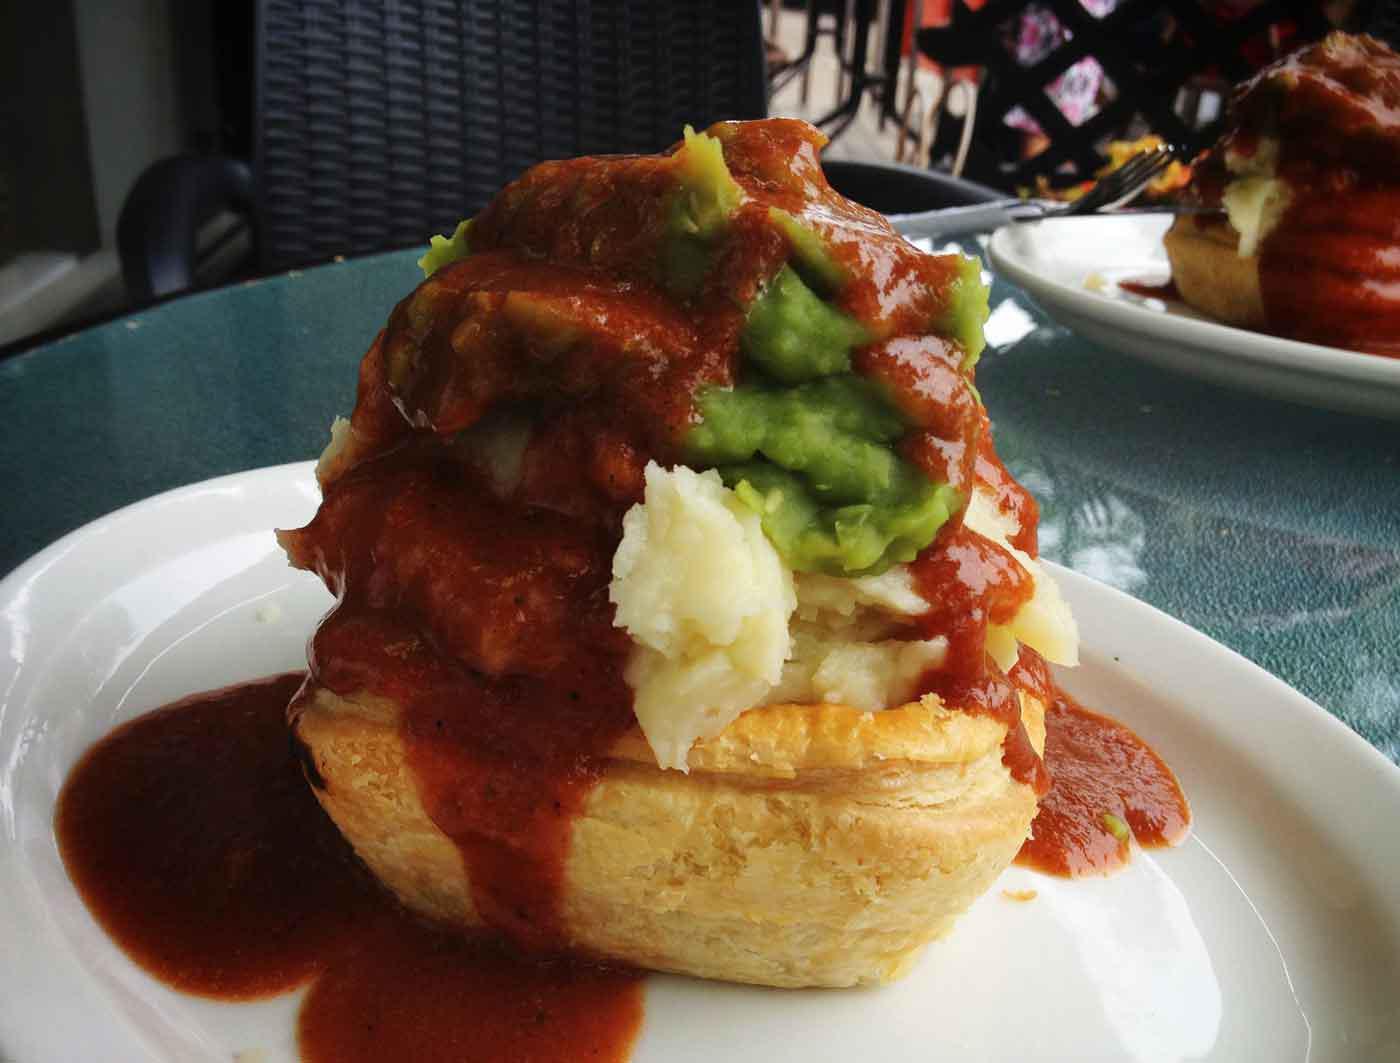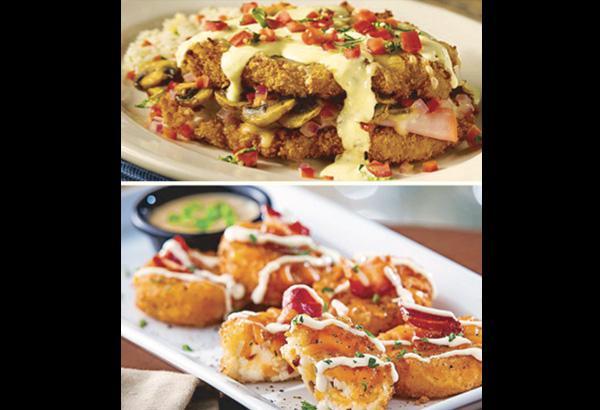The first image is the image on the left, the second image is the image on the right. Evaluate the accuracy of this statement regarding the images: "there is a visible orange vegetable in the image on the left side.". Is it true? Answer yes or no. No. The first image is the image on the left, the second image is the image on the right. Assess this claim about the two images: "There are absolutely NO forks present.". Correct or not? Answer yes or no. Yes. 